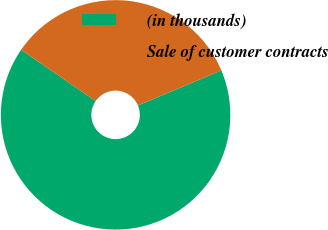<chart> <loc_0><loc_0><loc_500><loc_500><pie_chart><fcel>(in thousands)<fcel>Sale of customer contracts<nl><fcel>65.94%<fcel>34.06%<nl></chart> 